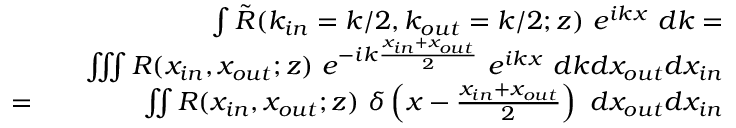Convert formula to latex. <formula><loc_0><loc_0><loc_500><loc_500>\begin{array} { r l r } & { \int { \tilde { R } ( k _ { i n } = k / 2 , k _ { o u t } = k / 2 ; z ) e ^ { i k x } d k } = } \\ & { \iiint { R ( x _ { i n } , x _ { o u t } ; z ) e ^ { - i k \frac { x _ { i n } + x _ { o u t } } { 2 } } e ^ { i k x } d k d x _ { o u t } d x _ { i n } } } \\ { = } & { \iint { R ( x _ { i n } , x _ { o u t } ; z ) \delta \left ( x - \frac { x _ { i n } + x _ { o u t } } { 2 } \right ) d x _ { o u t } d x _ { i n } } } \end{array}</formula> 